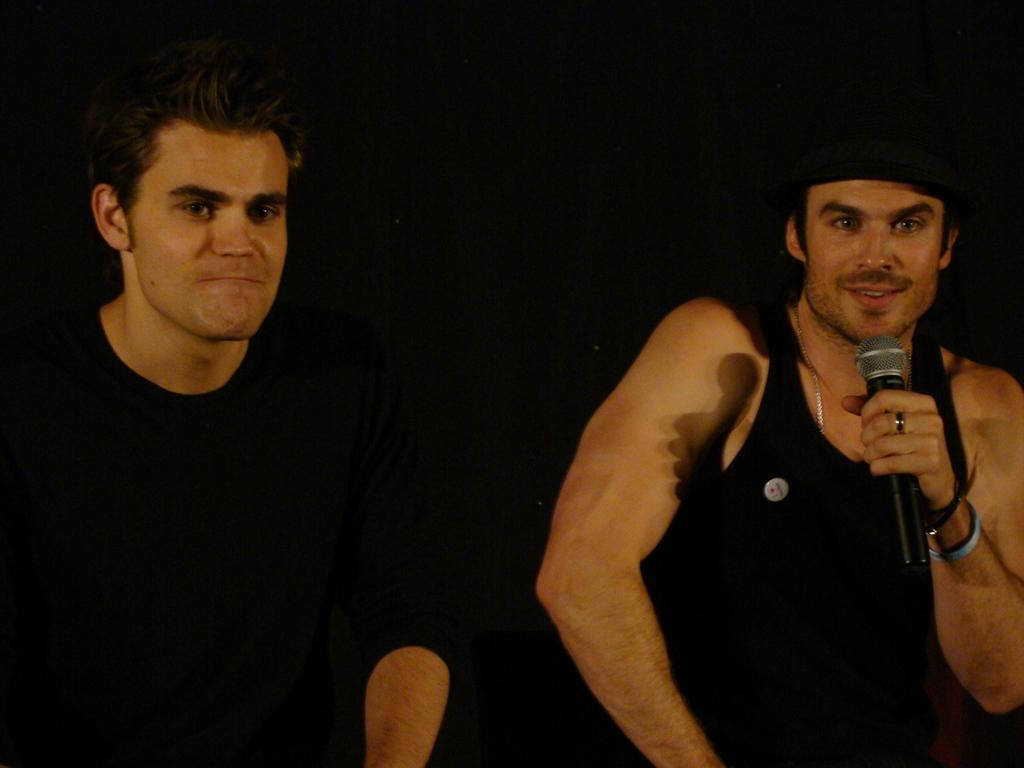How many people are in the image? There are two persons in the image. What are the people wearing? Both persons are wearing clothes. Where is the person on the right side of the image located? The person on the right side of the image is on the right side of the image. What is the person on the right side of the image holding? The person on the right side is holding a mic with his hand. What is the person on the right side of the image wearing on his head? The person on the right side is wearing a cap on his head. What type of ornament is hanging from the person's neck in the image? There is no ornament hanging from the person's neck in the image. What shape is the stamp on the person's forehead in the image? There is no stamp on the person's forehead in the image. 